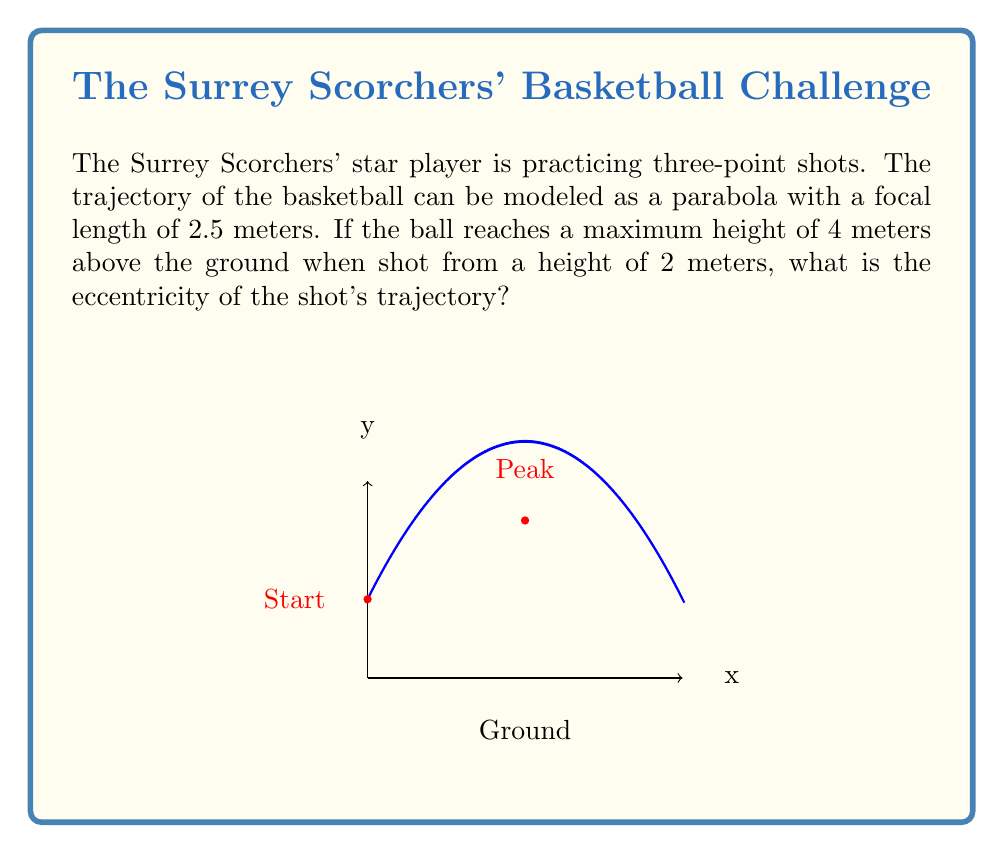Teach me how to tackle this problem. Let's approach this step-by-step:

1) The eccentricity of a parabola is always 1. However, we'll prove this using the given information.

2) For a parabola with vertex form $y = a(x-h)^2 + k$, where $(h,k)$ is the vertex:
   - The focal length $p = \frac{1}{4a}$
   - The eccentricity $e = \sqrt{1}$ = 1

3) We're given that the focal length $p = 2.5$ meters. So:

   $$2.5 = \frac{1}{4a}$$
   $$a = \frac{1}{10}$$

4) Now, let's find the vertex of the parabola:
   - The maximum height is 4 meters, so $k = 4$
   - The ball is shot from 2 meters high, so the height gained is 2 meters
   - In a parabola, the vertex is halfway between the start and peak horizontally

5) We can write the equation of the parabola:

   $$y = \frac{1}{10}(x-4)^2 + 4$$

6) The eccentricity is defined as $e = \frac{\text{distance from focus to directrix}}{2p}$

7) For a parabola, the distance from the focus to the directrix is always equal to $2p$, so:

   $$e = \frac{2p}{2p} = 1$$

Thus, we've confirmed that the eccentricity is 1, which is always true for parabolas.
Answer: 1 